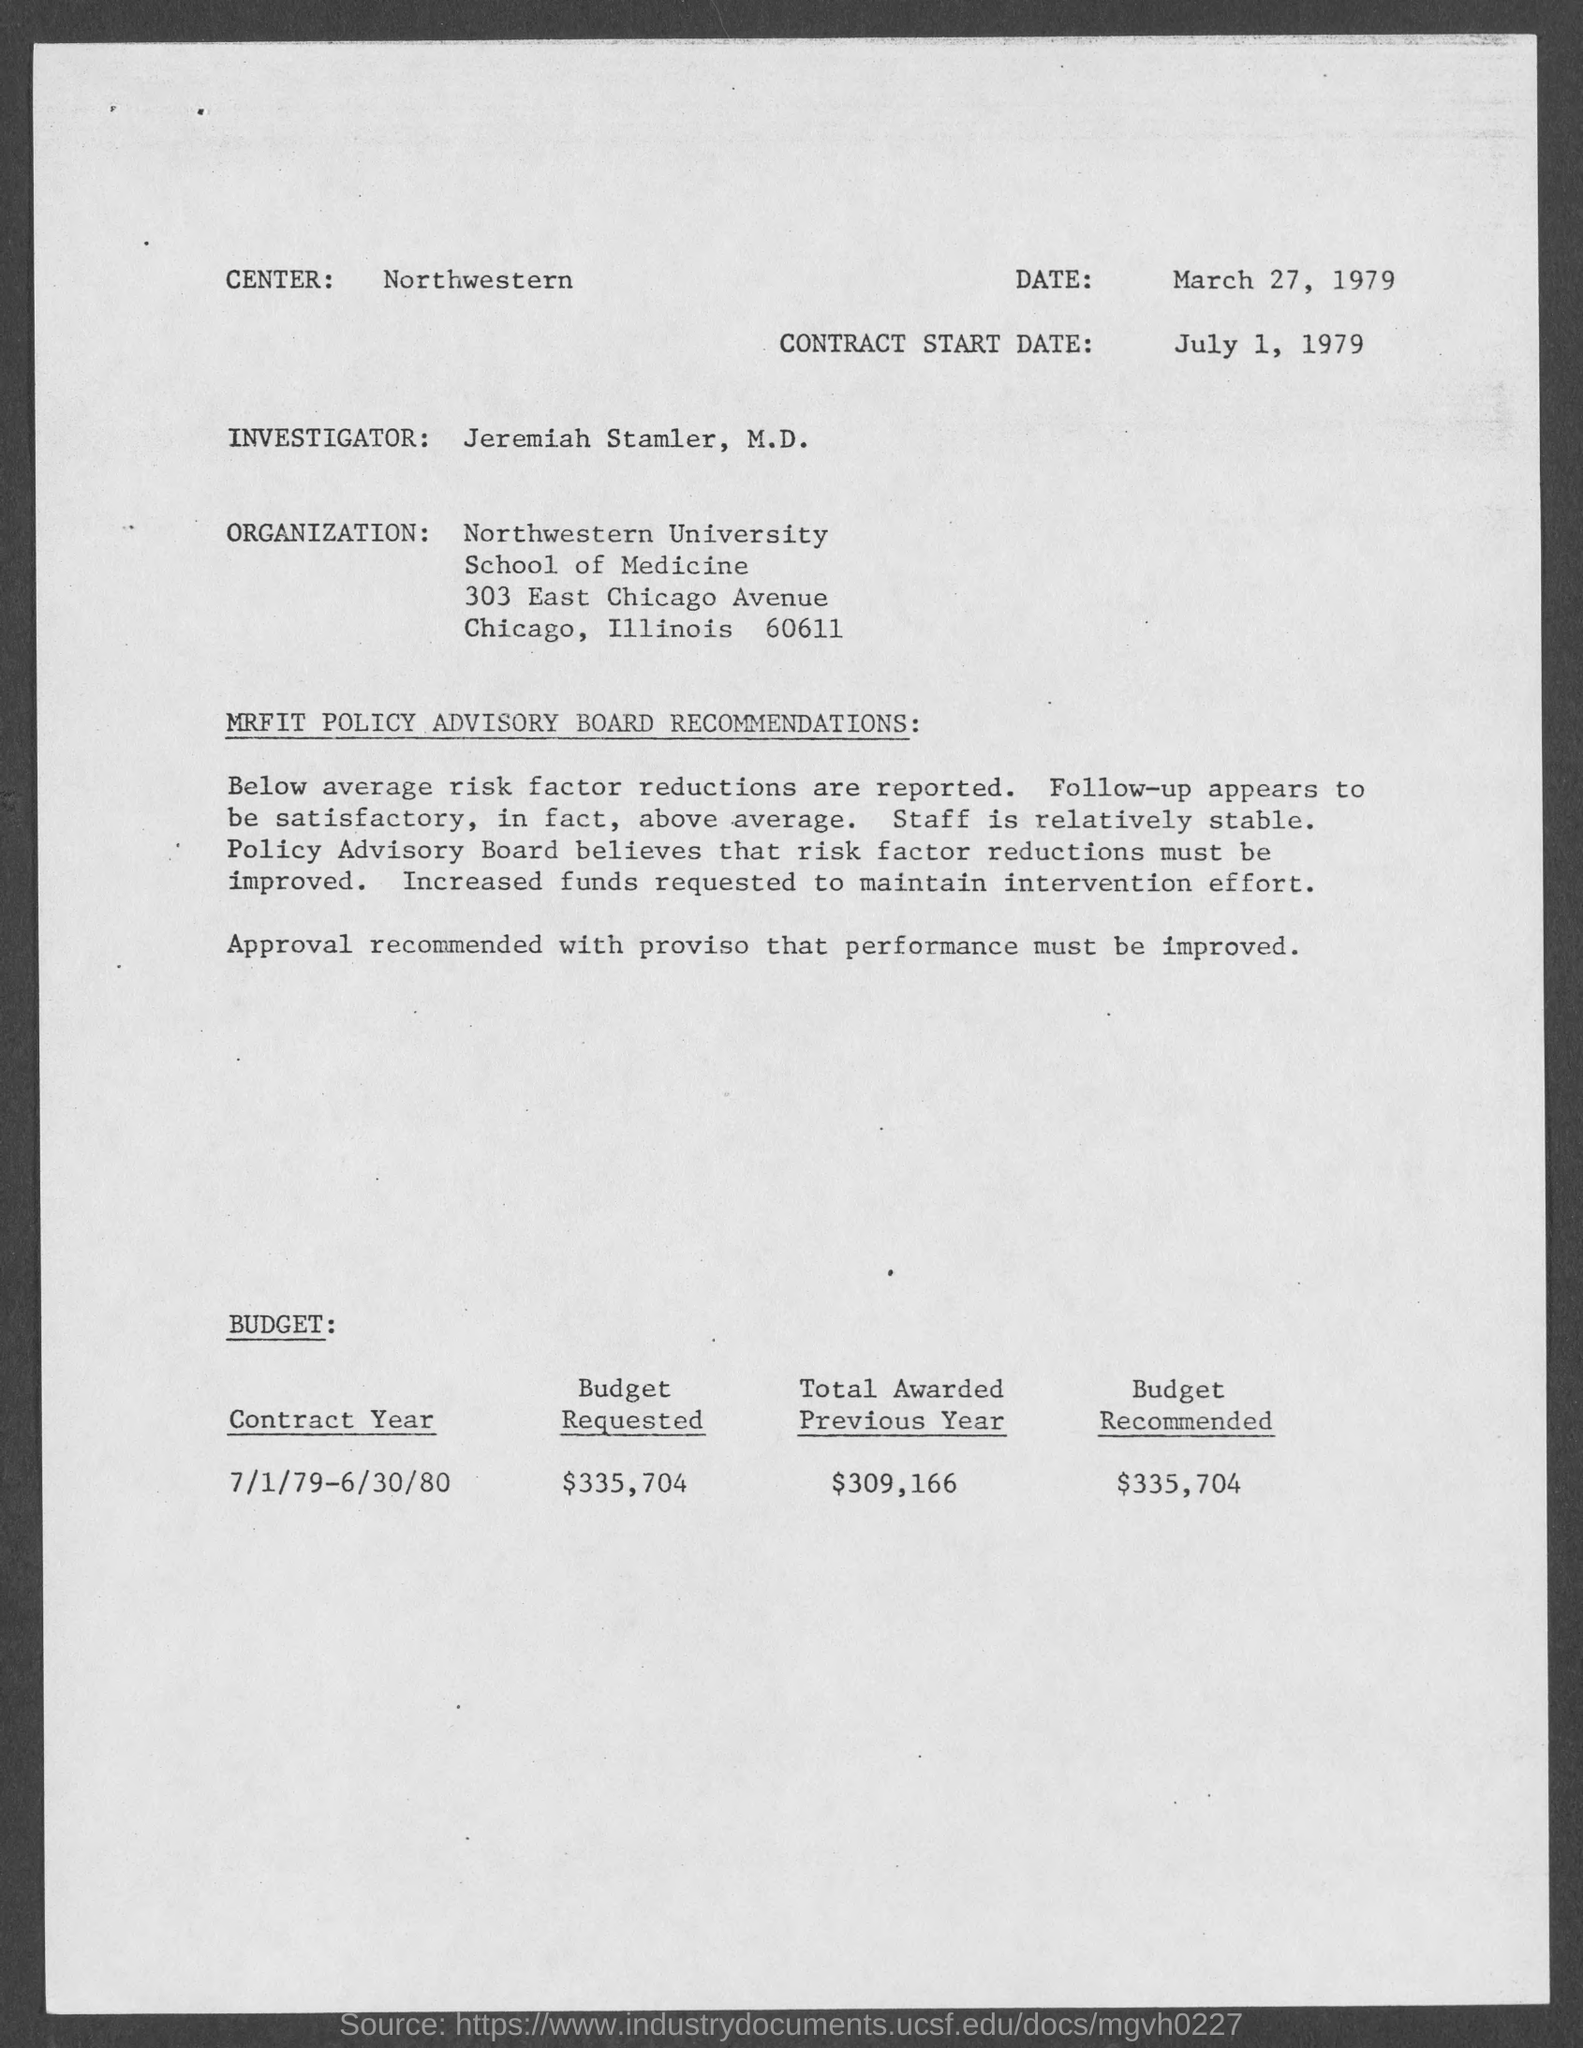Outline some significant characteristics in this image. The center is located in the northwestern region. The contract start date is July 1, 1979. The investigator is named Jeremiah Stamler. The requested budget is $335,704. In the previous year, a total of $309,166 was awarded. 